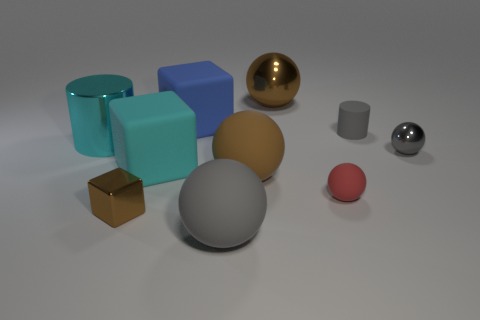Subtract all brown matte balls. How many balls are left? 4 Subtract all red balls. How many balls are left? 4 Subtract all cubes. How many objects are left? 7 Subtract 1 spheres. How many spheres are left? 4 Subtract all matte spheres. Subtract all tiny brown objects. How many objects are left? 6 Add 4 blue cubes. How many blue cubes are left? 5 Add 7 large brown cubes. How many large brown cubes exist? 7 Subtract 0 purple blocks. How many objects are left? 10 Subtract all gray spheres. Subtract all green cylinders. How many spheres are left? 3 Subtract all red cylinders. How many brown balls are left? 2 